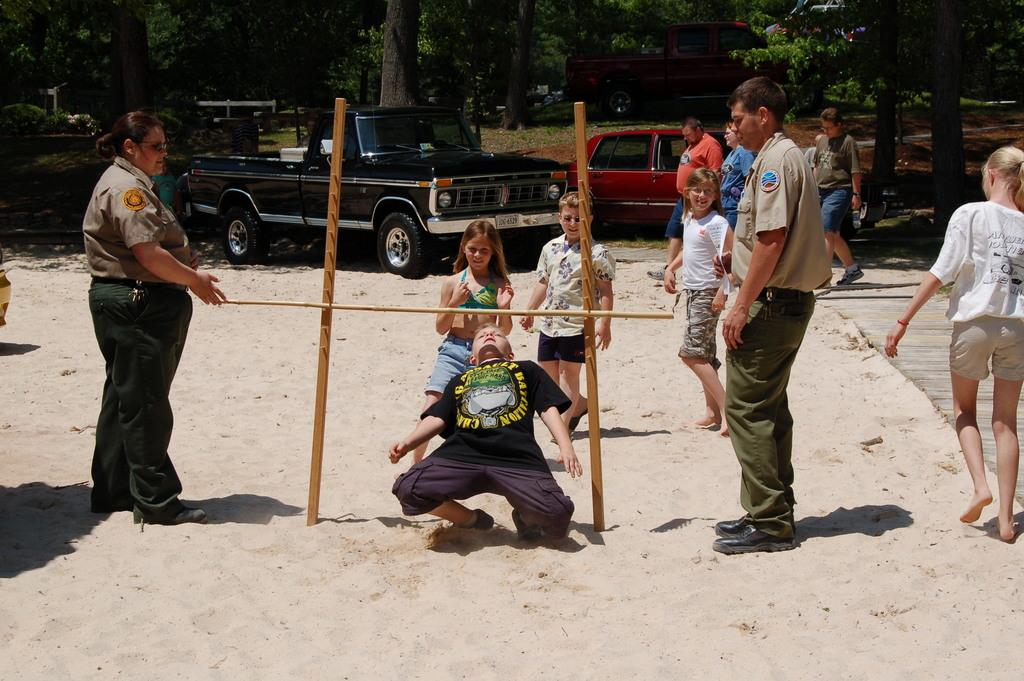Who or what can be seen in the image? There are people in the image. What type of terrain is visible in the image? There is sand visible in the image. What objects are present in the image? There are wooden sticks in the image. What can be seen in the background of the image? There are vehicles, trees, plants, and grass in the background of the image. What is the opinion of the basketball on the wooden sticks in the image? There is no basketball present in the image, so it cannot have an opinion on the wooden sticks. 